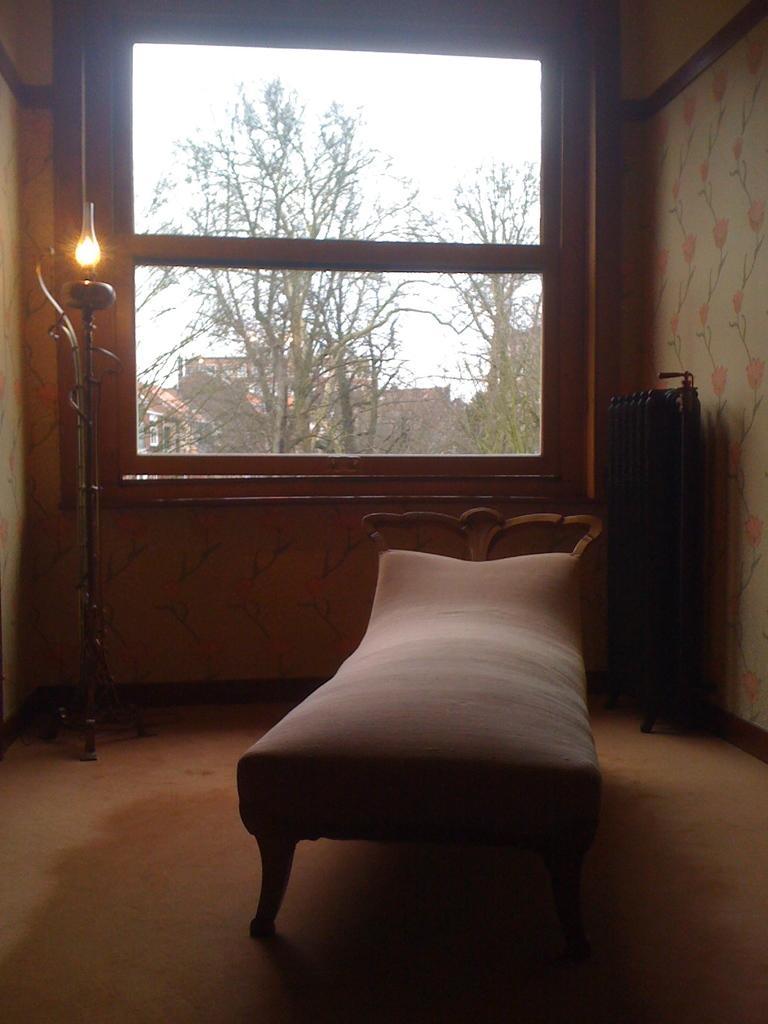In one or two sentences, can you explain what this image depicts? In this image there is a bed in the middle and there is a lamp on the left side. In the background there is a glass window through which we can see the buildings and trees. On the right side there is a wall on which there is a design. 